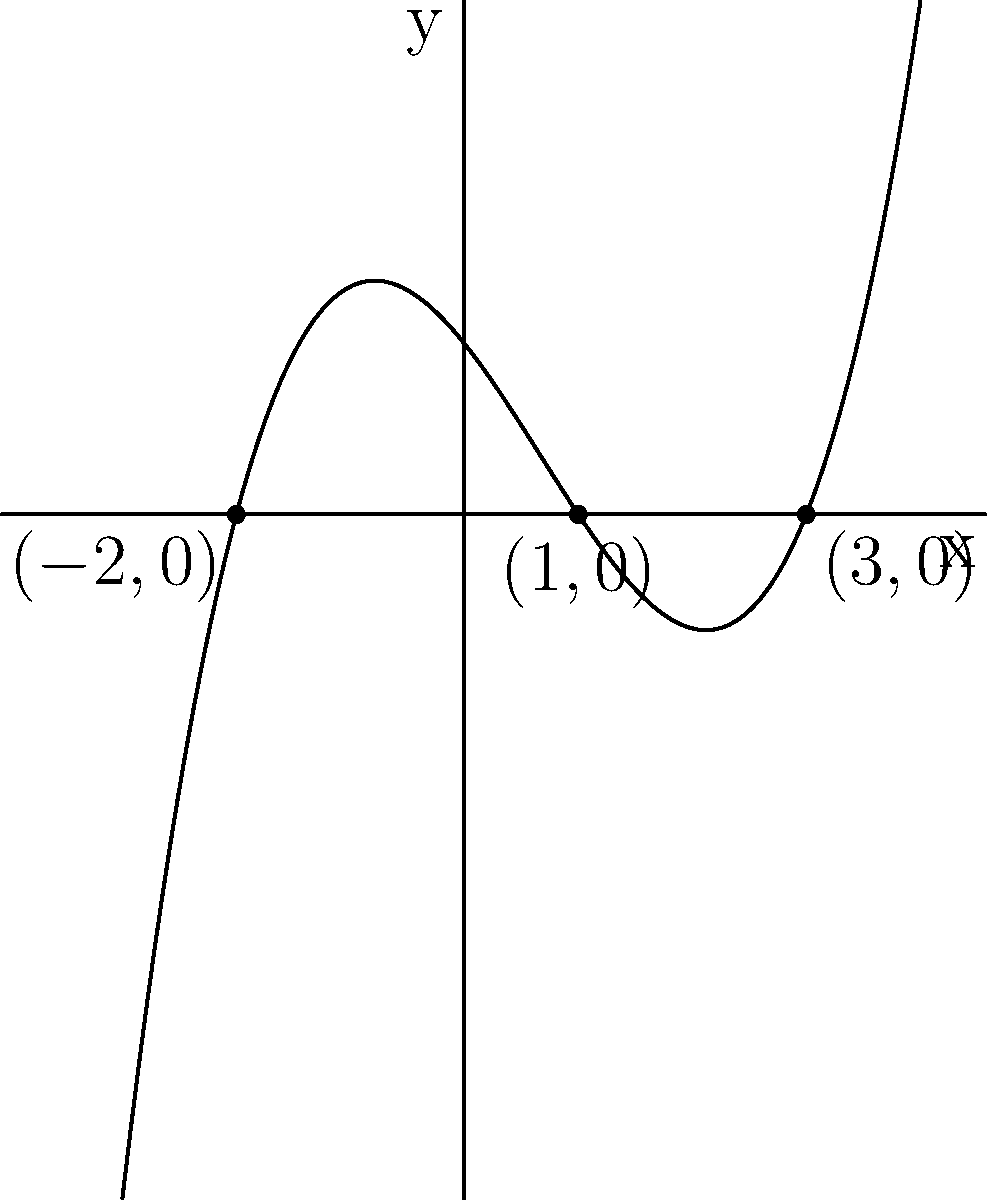As part of your advanced mathematics course, you're tasked with sketching a polynomial function. Given a polynomial function $f(x)$ with zeros at $x=-2$, $x=1$, and $x=3$, and knowing that the function has a positive leading coefficient, sketch the graph of $f(x)$. What is the degree of this polynomial? Let's approach this step-by-step:

1) First, we identify the zeros of the function: $x=-2$, $x=1$, and $x=3$. These are the x-intercepts of the graph.

2) We're told that the function has a positive leading coefficient. This means that as $x$ approaches positive infinity, $f(x)$ will also approach positive infinity. As $x$ approaches negative infinity, $f(x)$ will approach positive or negative infinity depending on whether the degree is even or odd.

3) To determine the behavior between the zeros:
   - The function will be positive when $x < -2$ (to the left of all zeros)
   - It will be negative between $-2$ and $1$
   - Positive between $1$ and $3$
   - Positive for $x > 3$ (to the right of all zeros)

4) The graph will cross the x-axis at each zero, changing from positive to negative or vice versa.

5) To determine the degree of the polynomial, we count the number of zeros. There are 3 distinct zeros, so the polynomial is of degree 3.

6) A degree 3 polynomial with a positive leading coefficient will start in the bottom left quadrant and end in the top right quadrant, consistent with the information given.

The sketch should show a curve that starts in the third quadrant, crosses the x-axis at $x=-2$, dips into the fourth quadrant, crosses back at $x=1$ into the first quadrant, crosses down at $x=3$, and then curves back up into the first quadrant.
Answer: The degree of the polynomial is 3. 